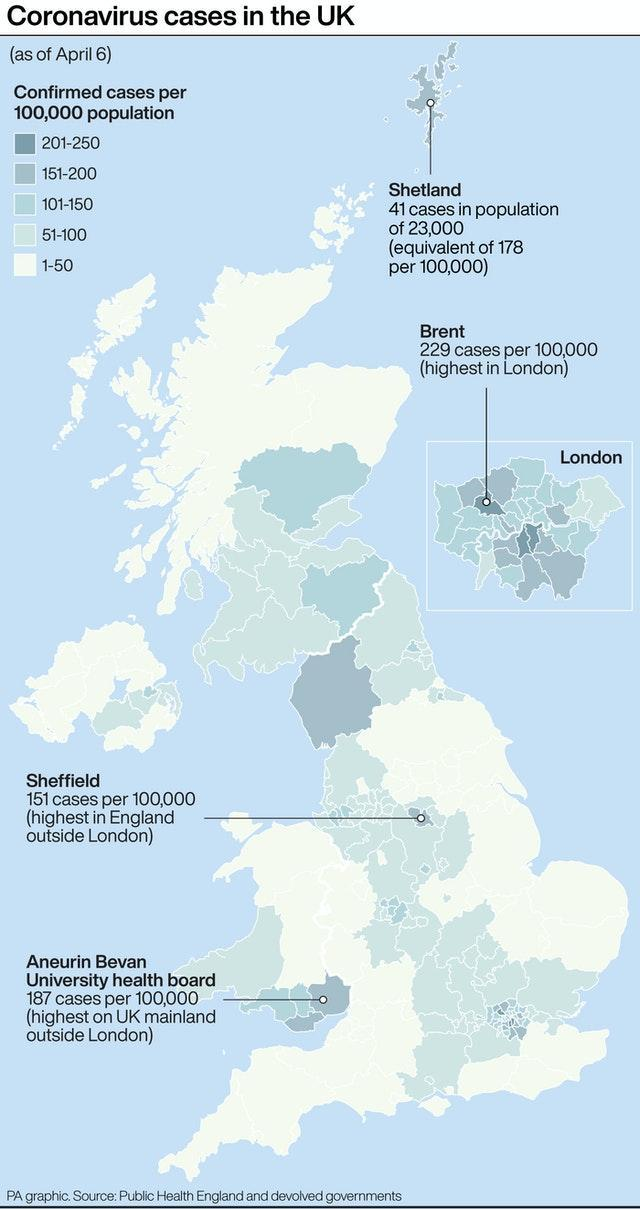How many places are shown in the map having more than 200 cases per 100,000 population?
Answer the question with a short phrase. 1 Among the places shown in the map having 150-200 cases/100k population, which place has the lowest number? Sheffield Which place shown in the map has more than 200 cases per 100,000 population? Brent Among the places shown in the map having 150-200 cases/100k population, which place has the highest number? Aneurin Bevan University health board Among the places shown in the map having 150-200 cases/100k population, which place has the second highest number? Shetland How many places are shown in the map having 150 - 200 cases per 100,000 population? 3 